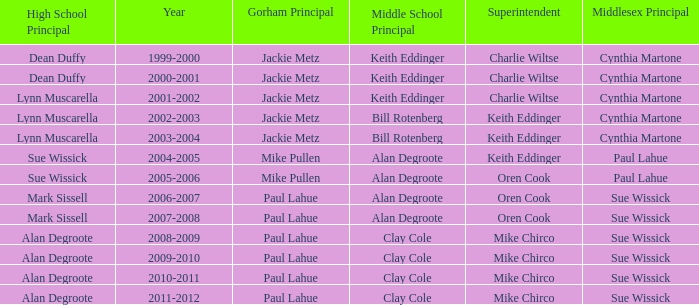Who was the gorham principal in 2010-2011? Paul Lahue. 